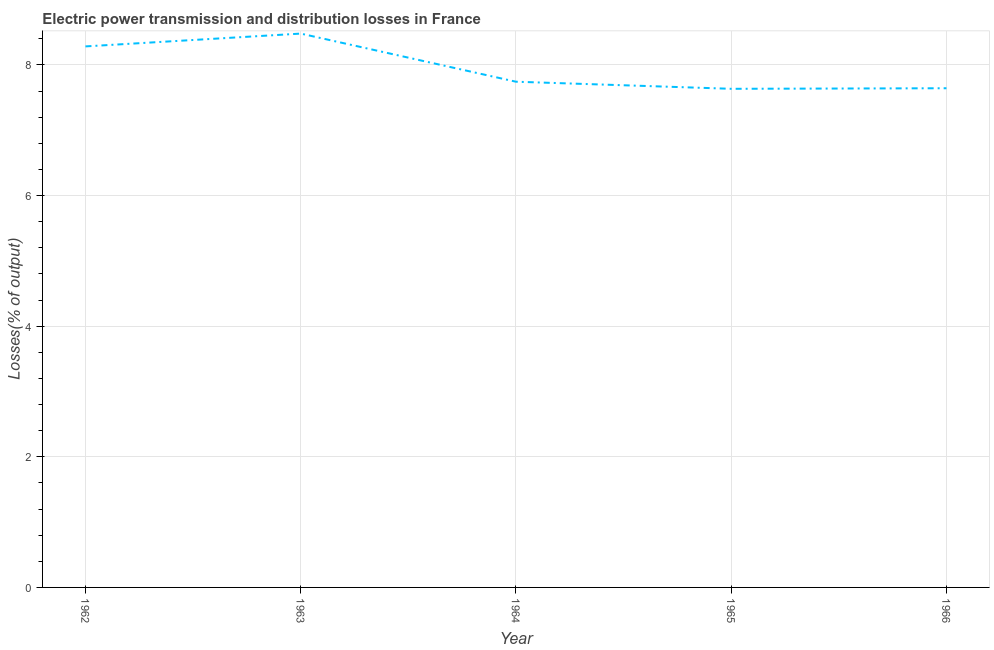What is the electric power transmission and distribution losses in 1962?
Keep it short and to the point. 8.28. Across all years, what is the maximum electric power transmission and distribution losses?
Your answer should be compact. 8.48. Across all years, what is the minimum electric power transmission and distribution losses?
Your response must be concise. 7.63. In which year was the electric power transmission and distribution losses minimum?
Provide a short and direct response. 1965. What is the sum of the electric power transmission and distribution losses?
Make the answer very short. 39.79. What is the difference between the electric power transmission and distribution losses in 1964 and 1965?
Ensure brevity in your answer.  0.11. What is the average electric power transmission and distribution losses per year?
Offer a terse response. 7.96. What is the median electric power transmission and distribution losses?
Keep it short and to the point. 7.74. What is the ratio of the electric power transmission and distribution losses in 1964 to that in 1965?
Offer a terse response. 1.01. Is the electric power transmission and distribution losses in 1964 less than that in 1966?
Ensure brevity in your answer.  No. Is the difference between the electric power transmission and distribution losses in 1962 and 1965 greater than the difference between any two years?
Your answer should be compact. No. What is the difference between the highest and the second highest electric power transmission and distribution losses?
Ensure brevity in your answer.  0.2. What is the difference between the highest and the lowest electric power transmission and distribution losses?
Your answer should be compact. 0.85. In how many years, is the electric power transmission and distribution losses greater than the average electric power transmission and distribution losses taken over all years?
Keep it short and to the point. 2. How many lines are there?
Ensure brevity in your answer.  1. How many years are there in the graph?
Your response must be concise. 5. What is the difference between two consecutive major ticks on the Y-axis?
Offer a terse response. 2. Are the values on the major ticks of Y-axis written in scientific E-notation?
Make the answer very short. No. What is the title of the graph?
Offer a very short reply. Electric power transmission and distribution losses in France. What is the label or title of the Y-axis?
Provide a short and direct response. Losses(% of output). What is the Losses(% of output) in 1962?
Provide a short and direct response. 8.28. What is the Losses(% of output) in 1963?
Provide a succinct answer. 8.48. What is the Losses(% of output) in 1964?
Provide a succinct answer. 7.74. What is the Losses(% of output) of 1965?
Keep it short and to the point. 7.63. What is the Losses(% of output) of 1966?
Provide a short and direct response. 7.64. What is the difference between the Losses(% of output) in 1962 and 1963?
Keep it short and to the point. -0.2. What is the difference between the Losses(% of output) in 1962 and 1964?
Offer a very short reply. 0.54. What is the difference between the Losses(% of output) in 1962 and 1965?
Your answer should be very brief. 0.65. What is the difference between the Losses(% of output) in 1962 and 1966?
Your answer should be compact. 0.64. What is the difference between the Losses(% of output) in 1963 and 1964?
Your answer should be very brief. 0.74. What is the difference between the Losses(% of output) in 1963 and 1965?
Provide a short and direct response. 0.85. What is the difference between the Losses(% of output) in 1963 and 1966?
Provide a succinct answer. 0.84. What is the difference between the Losses(% of output) in 1964 and 1965?
Offer a very short reply. 0.11. What is the difference between the Losses(% of output) in 1964 and 1966?
Your answer should be very brief. 0.1. What is the difference between the Losses(% of output) in 1965 and 1966?
Offer a terse response. -0.01. What is the ratio of the Losses(% of output) in 1962 to that in 1963?
Your answer should be very brief. 0.98. What is the ratio of the Losses(% of output) in 1962 to that in 1964?
Give a very brief answer. 1.07. What is the ratio of the Losses(% of output) in 1962 to that in 1965?
Provide a succinct answer. 1.08. What is the ratio of the Losses(% of output) in 1962 to that in 1966?
Your answer should be very brief. 1.08. What is the ratio of the Losses(% of output) in 1963 to that in 1964?
Offer a very short reply. 1.09. What is the ratio of the Losses(% of output) in 1963 to that in 1965?
Offer a very short reply. 1.11. What is the ratio of the Losses(% of output) in 1963 to that in 1966?
Offer a very short reply. 1.11. What is the ratio of the Losses(% of output) in 1964 to that in 1966?
Your response must be concise. 1.01. What is the ratio of the Losses(% of output) in 1965 to that in 1966?
Provide a succinct answer. 1. 